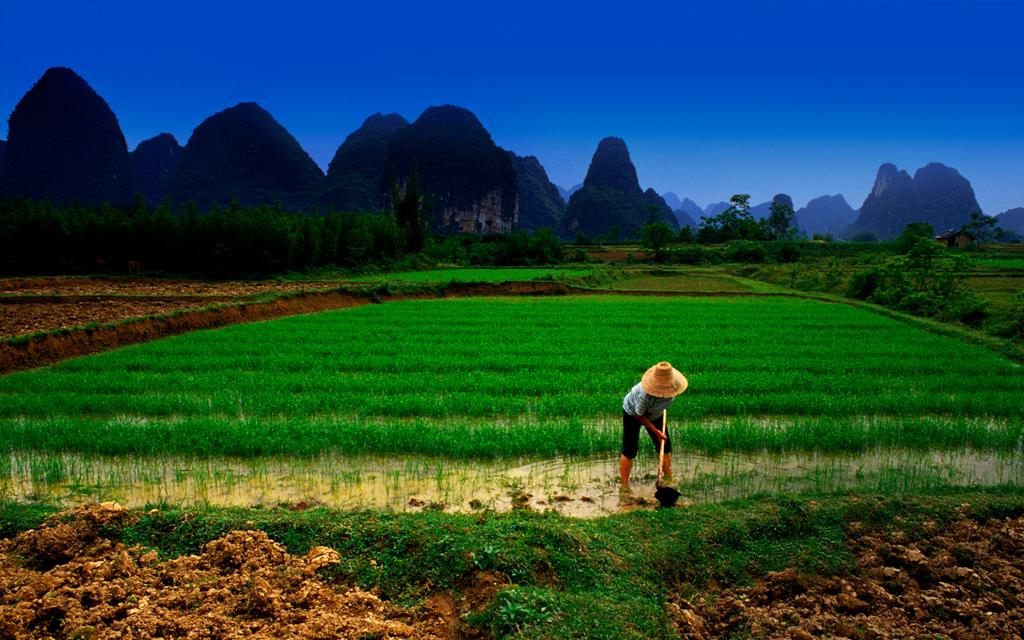Who is present in the image? There is a man in the image. What is the man doing in the image? The man is working in a field. What can be seen in the background of the image? There are trees, mountains, and a blue sky in the background of the image. What type of mist can be seen around the man in the image? There is no mist present in the image; the man is working in a field with clear visibility. 